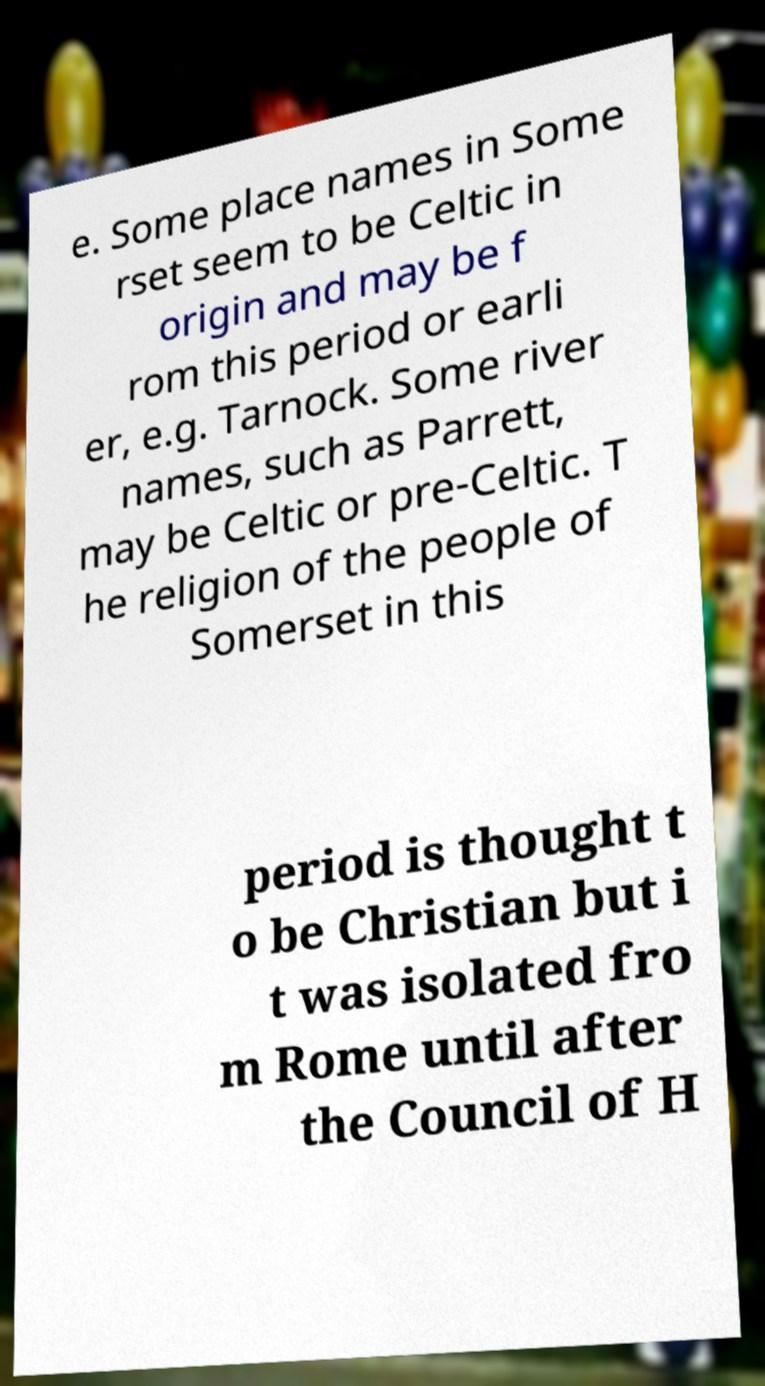What messages or text are displayed in this image? I need them in a readable, typed format. e. Some place names in Some rset seem to be Celtic in origin and may be f rom this period or earli er, e.g. Tarnock. Some river names, such as Parrett, may be Celtic or pre-Celtic. T he religion of the people of Somerset in this period is thought t o be Christian but i t was isolated fro m Rome until after the Council of H 